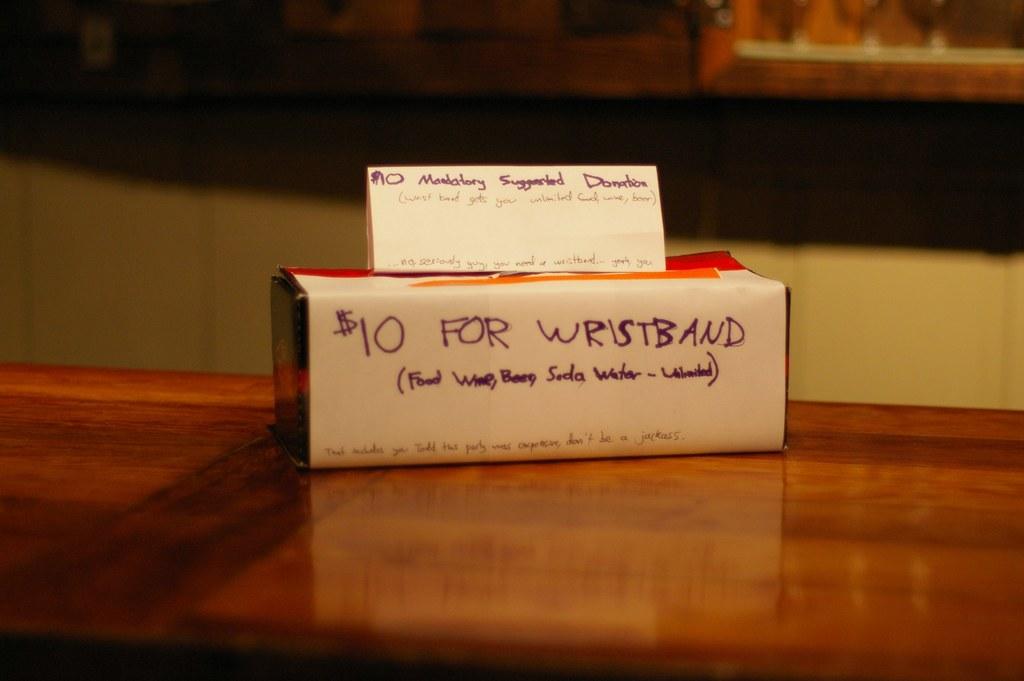Are those wristbands for sale?
Give a very brief answer. Yes. How much does a wristband cost?
Your answer should be compact. 10. 